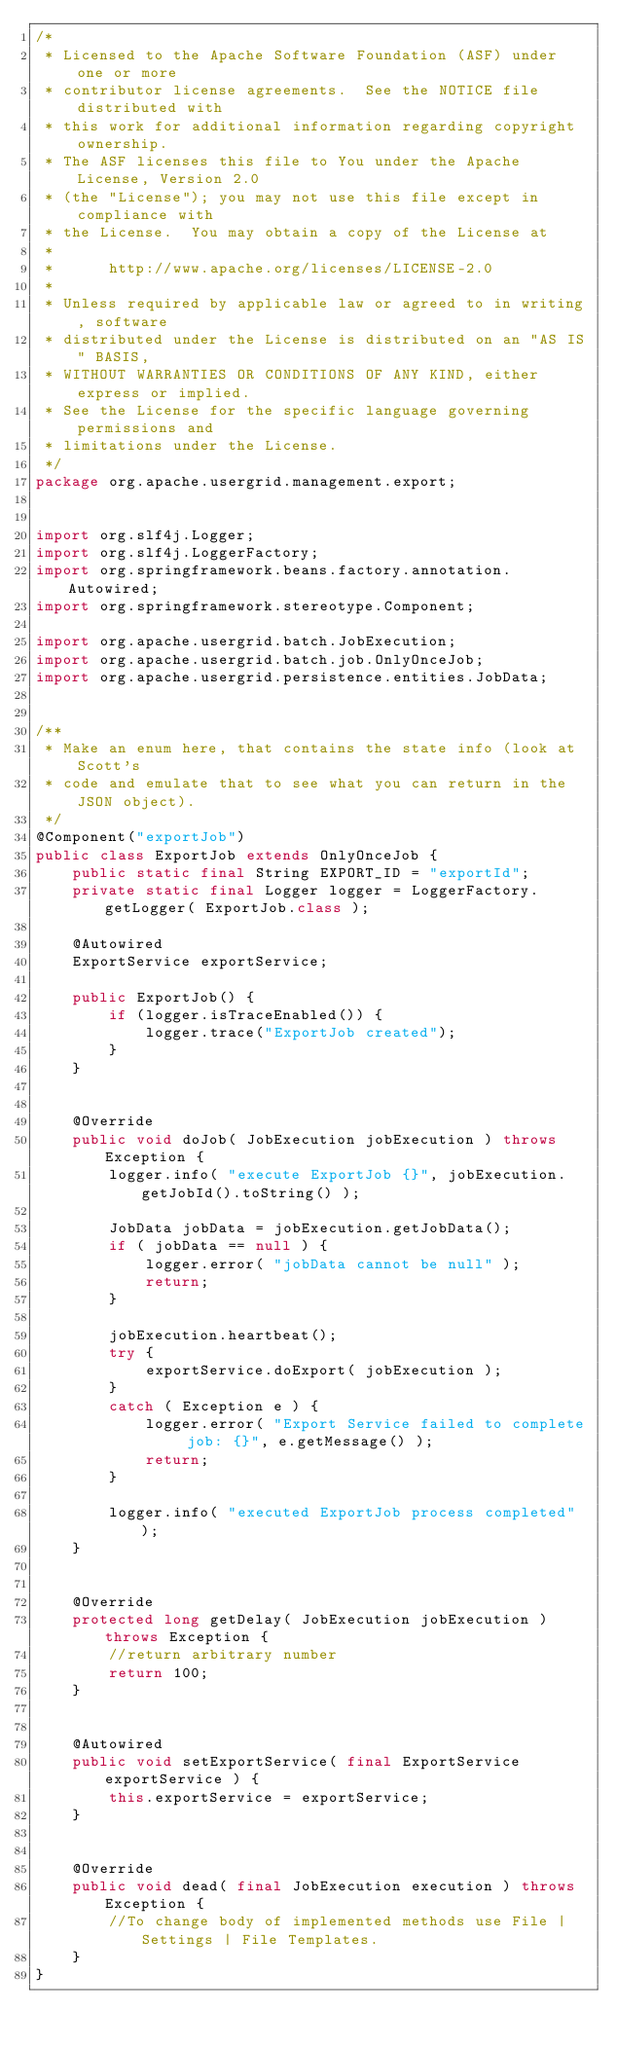Convert code to text. <code><loc_0><loc_0><loc_500><loc_500><_Java_>/*
 * Licensed to the Apache Software Foundation (ASF) under one or more
 * contributor license agreements.  See the NOTICE file distributed with
 * this work for additional information regarding copyright ownership.
 * The ASF licenses this file to You under the Apache License, Version 2.0
 * (the "License"); you may not use this file except in compliance with
 * the License.  You may obtain a copy of the License at
 *
 *      http://www.apache.org/licenses/LICENSE-2.0
 *
 * Unless required by applicable law or agreed to in writing, software
 * distributed under the License is distributed on an "AS IS" BASIS,
 * WITHOUT WARRANTIES OR CONDITIONS OF ANY KIND, either express or implied.
 * See the License for the specific language governing permissions and
 * limitations under the License.
 */
package org.apache.usergrid.management.export;


import org.slf4j.Logger;
import org.slf4j.LoggerFactory;
import org.springframework.beans.factory.annotation.Autowired;
import org.springframework.stereotype.Component;

import org.apache.usergrid.batch.JobExecution;
import org.apache.usergrid.batch.job.OnlyOnceJob;
import org.apache.usergrid.persistence.entities.JobData;


/**
 * Make an enum here, that contains the state info (look at Scott's
 * code and emulate that to see what you can return in the JSON object).
 */
@Component("exportJob")
public class ExportJob extends OnlyOnceJob {
    public static final String EXPORT_ID = "exportId";
    private static final Logger logger = LoggerFactory.getLogger( ExportJob.class );

    @Autowired
    ExportService exportService;

    public ExportJob() {
        if (logger.isTraceEnabled()) {
            logger.trace("ExportJob created");
        }
    }


    @Override
    public void doJob( JobExecution jobExecution ) throws Exception {
        logger.info( "execute ExportJob {}", jobExecution.getJobId().toString() );

        JobData jobData = jobExecution.getJobData();
        if ( jobData == null ) {
            logger.error( "jobData cannot be null" );
            return;
        }

        jobExecution.heartbeat();
        try {
            exportService.doExport( jobExecution );
        }
        catch ( Exception e ) {
            logger.error( "Export Service failed to complete job: {}", e.getMessage() );
            return;
        }

        logger.info( "executed ExportJob process completed" );
    }


    @Override
    protected long getDelay( JobExecution jobExecution ) throws Exception {
        //return arbitrary number
        return 100;
    }


    @Autowired
    public void setExportService( final ExportService exportService ) {
        this.exportService = exportService;
    }


    @Override
    public void dead( final JobExecution execution ) throws Exception {
        //To change body of implemented methods use File | Settings | File Templates.
    }
}
</code> 